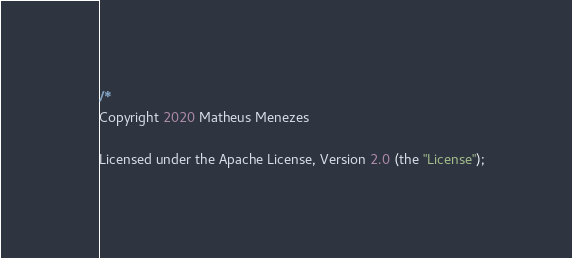<code> <loc_0><loc_0><loc_500><loc_500><_Kotlin_>/*
Copyright 2020 Matheus Menezes

Licensed under the Apache License, Version 2.0 (the "License");</code> 